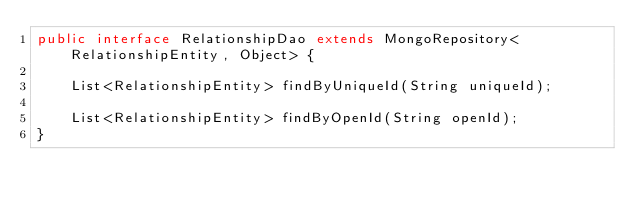Convert code to text. <code><loc_0><loc_0><loc_500><loc_500><_Java_>public interface RelationshipDao extends MongoRepository<RelationshipEntity, Object> {

    List<RelationshipEntity> findByUniqueId(String uniqueId);

    List<RelationshipEntity> findByOpenId(String openId);
}
</code> 